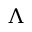<formula> <loc_0><loc_0><loc_500><loc_500>\Lambda</formula> 